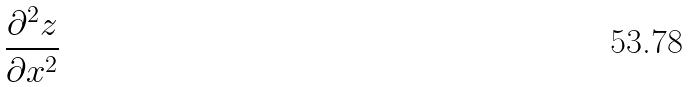Convert formula to latex. <formula><loc_0><loc_0><loc_500><loc_500>\frac { \partial ^ { 2 } z } { \partial x ^ { 2 } }</formula> 